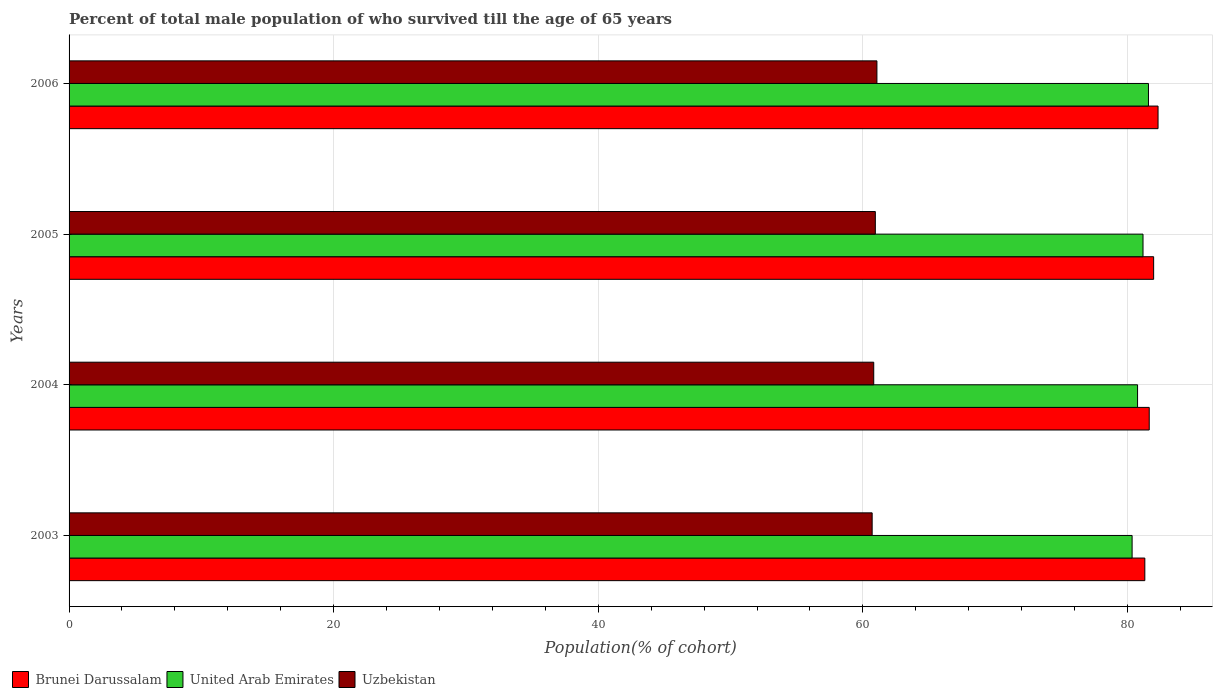How many groups of bars are there?
Offer a terse response. 4. Are the number of bars per tick equal to the number of legend labels?
Make the answer very short. Yes. How many bars are there on the 1st tick from the top?
Your answer should be compact. 3. How many bars are there on the 2nd tick from the bottom?
Offer a very short reply. 3. What is the percentage of total male population who survived till the age of 65 years in Uzbekistan in 2004?
Your response must be concise. 60.82. Across all years, what is the maximum percentage of total male population who survived till the age of 65 years in United Arab Emirates?
Offer a very short reply. 81.59. Across all years, what is the minimum percentage of total male population who survived till the age of 65 years in United Arab Emirates?
Make the answer very short. 80.35. What is the total percentage of total male population who survived till the age of 65 years in United Arab Emirates in the graph?
Ensure brevity in your answer.  323.87. What is the difference between the percentage of total male population who survived till the age of 65 years in United Arab Emirates in 2005 and that in 2006?
Your answer should be very brief. -0.41. What is the difference between the percentage of total male population who survived till the age of 65 years in Uzbekistan in 2006 and the percentage of total male population who survived till the age of 65 years in United Arab Emirates in 2003?
Your response must be concise. -19.29. What is the average percentage of total male population who survived till the age of 65 years in United Arab Emirates per year?
Your answer should be compact. 80.97. In the year 2006, what is the difference between the percentage of total male population who survived till the age of 65 years in Uzbekistan and percentage of total male population who survived till the age of 65 years in United Arab Emirates?
Keep it short and to the point. -20.52. What is the ratio of the percentage of total male population who survived till the age of 65 years in Uzbekistan in 2003 to that in 2006?
Provide a succinct answer. 0.99. Is the difference between the percentage of total male population who survived till the age of 65 years in Uzbekistan in 2004 and 2005 greater than the difference between the percentage of total male population who survived till the age of 65 years in United Arab Emirates in 2004 and 2005?
Give a very brief answer. Yes. What is the difference between the highest and the second highest percentage of total male population who survived till the age of 65 years in Uzbekistan?
Give a very brief answer. 0.12. What is the difference between the highest and the lowest percentage of total male population who survived till the age of 65 years in United Arab Emirates?
Offer a terse response. 1.24. Is the sum of the percentage of total male population who survived till the age of 65 years in Uzbekistan in 2003 and 2004 greater than the maximum percentage of total male population who survived till the age of 65 years in United Arab Emirates across all years?
Your response must be concise. Yes. What does the 1st bar from the top in 2004 represents?
Keep it short and to the point. Uzbekistan. What does the 1st bar from the bottom in 2003 represents?
Your answer should be compact. Brunei Darussalam. Is it the case that in every year, the sum of the percentage of total male population who survived till the age of 65 years in United Arab Emirates and percentage of total male population who survived till the age of 65 years in Brunei Darussalam is greater than the percentage of total male population who survived till the age of 65 years in Uzbekistan?
Offer a very short reply. Yes. What is the difference between two consecutive major ticks on the X-axis?
Ensure brevity in your answer.  20. Are the values on the major ticks of X-axis written in scientific E-notation?
Offer a very short reply. No. Does the graph contain grids?
Ensure brevity in your answer.  Yes. Where does the legend appear in the graph?
Give a very brief answer. Bottom left. How many legend labels are there?
Offer a very short reply. 3. How are the legend labels stacked?
Ensure brevity in your answer.  Horizontal. What is the title of the graph?
Make the answer very short. Percent of total male population of who survived till the age of 65 years. What is the label or title of the X-axis?
Provide a short and direct response. Population(% of cohort). What is the Population(% of cohort) in Brunei Darussalam in 2003?
Ensure brevity in your answer.  81.31. What is the Population(% of cohort) in United Arab Emirates in 2003?
Provide a short and direct response. 80.35. What is the Population(% of cohort) in Uzbekistan in 2003?
Your response must be concise. 60.7. What is the Population(% of cohort) in Brunei Darussalam in 2004?
Provide a succinct answer. 81.64. What is the Population(% of cohort) of United Arab Emirates in 2004?
Provide a succinct answer. 80.76. What is the Population(% of cohort) in Uzbekistan in 2004?
Your answer should be very brief. 60.82. What is the Population(% of cohort) of Brunei Darussalam in 2005?
Your response must be concise. 81.98. What is the Population(% of cohort) of United Arab Emirates in 2005?
Your answer should be compact. 81.17. What is the Population(% of cohort) of Uzbekistan in 2005?
Make the answer very short. 60.94. What is the Population(% of cohort) in Brunei Darussalam in 2006?
Your answer should be compact. 82.31. What is the Population(% of cohort) of United Arab Emirates in 2006?
Provide a succinct answer. 81.59. What is the Population(% of cohort) in Uzbekistan in 2006?
Your answer should be very brief. 61.06. Across all years, what is the maximum Population(% of cohort) in Brunei Darussalam?
Give a very brief answer. 82.31. Across all years, what is the maximum Population(% of cohort) in United Arab Emirates?
Offer a very short reply. 81.59. Across all years, what is the maximum Population(% of cohort) of Uzbekistan?
Offer a terse response. 61.06. Across all years, what is the minimum Population(% of cohort) in Brunei Darussalam?
Ensure brevity in your answer.  81.31. Across all years, what is the minimum Population(% of cohort) in United Arab Emirates?
Offer a terse response. 80.35. Across all years, what is the minimum Population(% of cohort) in Uzbekistan?
Your answer should be compact. 60.7. What is the total Population(% of cohort) in Brunei Darussalam in the graph?
Offer a very short reply. 327.24. What is the total Population(% of cohort) of United Arab Emirates in the graph?
Your answer should be very brief. 323.87. What is the total Population(% of cohort) of Uzbekistan in the graph?
Provide a short and direct response. 243.52. What is the difference between the Population(% of cohort) of Brunei Darussalam in 2003 and that in 2004?
Give a very brief answer. -0.33. What is the difference between the Population(% of cohort) of United Arab Emirates in 2003 and that in 2004?
Make the answer very short. -0.41. What is the difference between the Population(% of cohort) of Uzbekistan in 2003 and that in 2004?
Provide a succinct answer. -0.12. What is the difference between the Population(% of cohort) of Brunei Darussalam in 2003 and that in 2005?
Ensure brevity in your answer.  -0.67. What is the difference between the Population(% of cohort) of United Arab Emirates in 2003 and that in 2005?
Ensure brevity in your answer.  -0.82. What is the difference between the Population(% of cohort) in Uzbekistan in 2003 and that in 2005?
Your answer should be very brief. -0.24. What is the difference between the Population(% of cohort) in Brunei Darussalam in 2003 and that in 2006?
Provide a short and direct response. -1. What is the difference between the Population(% of cohort) in United Arab Emirates in 2003 and that in 2006?
Your response must be concise. -1.24. What is the difference between the Population(% of cohort) of Uzbekistan in 2003 and that in 2006?
Provide a succinct answer. -0.36. What is the difference between the Population(% of cohort) of Brunei Darussalam in 2004 and that in 2005?
Your response must be concise. -0.33. What is the difference between the Population(% of cohort) in United Arab Emirates in 2004 and that in 2005?
Offer a very short reply. -0.41. What is the difference between the Population(% of cohort) in Uzbekistan in 2004 and that in 2005?
Offer a terse response. -0.12. What is the difference between the Population(% of cohort) of Brunei Darussalam in 2004 and that in 2006?
Your answer should be very brief. -0.67. What is the difference between the Population(% of cohort) in United Arab Emirates in 2004 and that in 2006?
Your response must be concise. -0.82. What is the difference between the Population(% of cohort) in Uzbekistan in 2004 and that in 2006?
Keep it short and to the point. -0.24. What is the difference between the Population(% of cohort) of Brunei Darussalam in 2005 and that in 2006?
Make the answer very short. -0.33. What is the difference between the Population(% of cohort) in United Arab Emirates in 2005 and that in 2006?
Offer a terse response. -0.41. What is the difference between the Population(% of cohort) of Uzbekistan in 2005 and that in 2006?
Offer a terse response. -0.12. What is the difference between the Population(% of cohort) of Brunei Darussalam in 2003 and the Population(% of cohort) of United Arab Emirates in 2004?
Your response must be concise. 0.55. What is the difference between the Population(% of cohort) in Brunei Darussalam in 2003 and the Population(% of cohort) in Uzbekistan in 2004?
Provide a succinct answer. 20.49. What is the difference between the Population(% of cohort) of United Arab Emirates in 2003 and the Population(% of cohort) of Uzbekistan in 2004?
Your answer should be very brief. 19.53. What is the difference between the Population(% of cohort) in Brunei Darussalam in 2003 and the Population(% of cohort) in United Arab Emirates in 2005?
Your answer should be very brief. 0.14. What is the difference between the Population(% of cohort) in Brunei Darussalam in 2003 and the Population(% of cohort) in Uzbekistan in 2005?
Provide a short and direct response. 20.37. What is the difference between the Population(% of cohort) in United Arab Emirates in 2003 and the Population(% of cohort) in Uzbekistan in 2005?
Offer a very short reply. 19.41. What is the difference between the Population(% of cohort) of Brunei Darussalam in 2003 and the Population(% of cohort) of United Arab Emirates in 2006?
Ensure brevity in your answer.  -0.27. What is the difference between the Population(% of cohort) in Brunei Darussalam in 2003 and the Population(% of cohort) in Uzbekistan in 2006?
Provide a succinct answer. 20.25. What is the difference between the Population(% of cohort) of United Arab Emirates in 2003 and the Population(% of cohort) of Uzbekistan in 2006?
Keep it short and to the point. 19.29. What is the difference between the Population(% of cohort) of Brunei Darussalam in 2004 and the Population(% of cohort) of United Arab Emirates in 2005?
Offer a terse response. 0.47. What is the difference between the Population(% of cohort) of Brunei Darussalam in 2004 and the Population(% of cohort) of Uzbekistan in 2005?
Your answer should be very brief. 20.7. What is the difference between the Population(% of cohort) of United Arab Emirates in 2004 and the Population(% of cohort) of Uzbekistan in 2005?
Your response must be concise. 19.82. What is the difference between the Population(% of cohort) of Brunei Darussalam in 2004 and the Population(% of cohort) of United Arab Emirates in 2006?
Provide a short and direct response. 0.06. What is the difference between the Population(% of cohort) of Brunei Darussalam in 2004 and the Population(% of cohort) of Uzbekistan in 2006?
Your response must be concise. 20.58. What is the difference between the Population(% of cohort) of United Arab Emirates in 2004 and the Population(% of cohort) of Uzbekistan in 2006?
Give a very brief answer. 19.7. What is the difference between the Population(% of cohort) of Brunei Darussalam in 2005 and the Population(% of cohort) of United Arab Emirates in 2006?
Your answer should be very brief. 0.39. What is the difference between the Population(% of cohort) in Brunei Darussalam in 2005 and the Population(% of cohort) in Uzbekistan in 2006?
Your answer should be compact. 20.92. What is the difference between the Population(% of cohort) of United Arab Emirates in 2005 and the Population(% of cohort) of Uzbekistan in 2006?
Give a very brief answer. 20.11. What is the average Population(% of cohort) in Brunei Darussalam per year?
Your answer should be very brief. 81.81. What is the average Population(% of cohort) of United Arab Emirates per year?
Offer a terse response. 80.97. What is the average Population(% of cohort) of Uzbekistan per year?
Keep it short and to the point. 60.88. In the year 2003, what is the difference between the Population(% of cohort) in Brunei Darussalam and Population(% of cohort) in United Arab Emirates?
Keep it short and to the point. 0.96. In the year 2003, what is the difference between the Population(% of cohort) of Brunei Darussalam and Population(% of cohort) of Uzbekistan?
Offer a terse response. 20.61. In the year 2003, what is the difference between the Population(% of cohort) in United Arab Emirates and Population(% of cohort) in Uzbekistan?
Your response must be concise. 19.65. In the year 2004, what is the difference between the Population(% of cohort) of Brunei Darussalam and Population(% of cohort) of United Arab Emirates?
Provide a succinct answer. 0.88. In the year 2004, what is the difference between the Population(% of cohort) of Brunei Darussalam and Population(% of cohort) of Uzbekistan?
Your answer should be compact. 20.82. In the year 2004, what is the difference between the Population(% of cohort) of United Arab Emirates and Population(% of cohort) of Uzbekistan?
Make the answer very short. 19.94. In the year 2005, what is the difference between the Population(% of cohort) in Brunei Darussalam and Population(% of cohort) in United Arab Emirates?
Make the answer very short. 0.8. In the year 2005, what is the difference between the Population(% of cohort) in Brunei Darussalam and Population(% of cohort) in Uzbekistan?
Give a very brief answer. 21.04. In the year 2005, what is the difference between the Population(% of cohort) in United Arab Emirates and Population(% of cohort) in Uzbekistan?
Make the answer very short. 20.23. In the year 2006, what is the difference between the Population(% of cohort) of Brunei Darussalam and Population(% of cohort) of United Arab Emirates?
Ensure brevity in your answer.  0.72. In the year 2006, what is the difference between the Population(% of cohort) in Brunei Darussalam and Population(% of cohort) in Uzbekistan?
Give a very brief answer. 21.25. In the year 2006, what is the difference between the Population(% of cohort) of United Arab Emirates and Population(% of cohort) of Uzbekistan?
Give a very brief answer. 20.52. What is the ratio of the Population(% of cohort) of Brunei Darussalam in 2003 to that in 2005?
Your answer should be very brief. 0.99. What is the ratio of the Population(% of cohort) in Uzbekistan in 2003 to that in 2005?
Offer a terse response. 1. What is the ratio of the Population(% of cohort) of Brunei Darussalam in 2003 to that in 2006?
Your answer should be very brief. 0.99. What is the ratio of the Population(% of cohort) in United Arab Emirates in 2003 to that in 2006?
Your answer should be very brief. 0.98. What is the ratio of the Population(% of cohort) of Uzbekistan in 2003 to that in 2006?
Provide a succinct answer. 0.99. What is the ratio of the Population(% of cohort) in United Arab Emirates in 2004 to that in 2005?
Ensure brevity in your answer.  0.99. What is the ratio of the Population(% of cohort) in Uzbekistan in 2004 to that in 2005?
Provide a succinct answer. 1. What is the ratio of the Population(% of cohort) of Uzbekistan in 2004 to that in 2006?
Give a very brief answer. 1. What is the ratio of the Population(% of cohort) in Uzbekistan in 2005 to that in 2006?
Offer a very short reply. 1. What is the difference between the highest and the second highest Population(% of cohort) in Brunei Darussalam?
Provide a short and direct response. 0.33. What is the difference between the highest and the second highest Population(% of cohort) of United Arab Emirates?
Provide a short and direct response. 0.41. What is the difference between the highest and the second highest Population(% of cohort) in Uzbekistan?
Your response must be concise. 0.12. What is the difference between the highest and the lowest Population(% of cohort) of United Arab Emirates?
Provide a succinct answer. 1.24. What is the difference between the highest and the lowest Population(% of cohort) in Uzbekistan?
Your answer should be very brief. 0.36. 